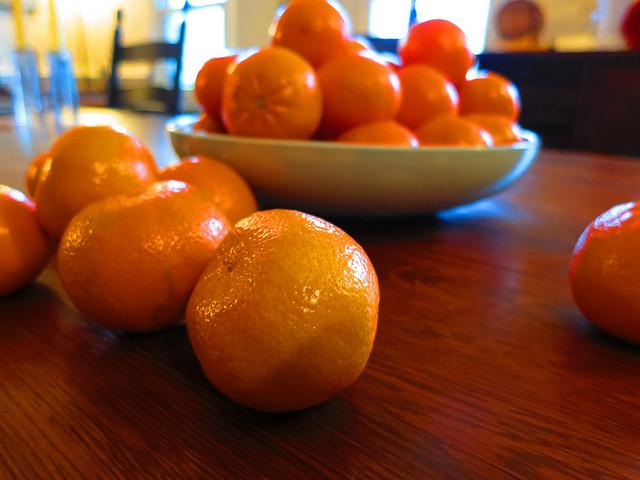Is the bowl full of fruit?
Short answer required. Yes. How many of the tangerines are not in the bowl?
Concise answer only. 6. How many oranges are there?
Write a very short answer. 17. Are these tangelos?
Answer briefly. Yes. 